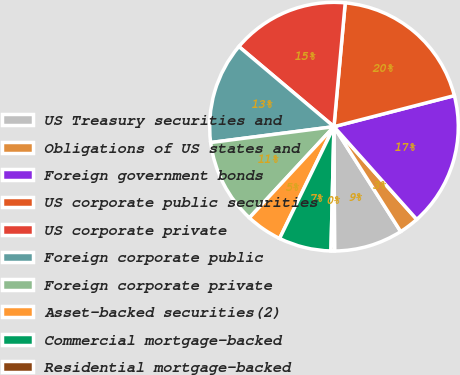Convert chart. <chart><loc_0><loc_0><loc_500><loc_500><pie_chart><fcel>US Treasury securities and<fcel>Obligations of US states and<fcel>Foreign government bonds<fcel>US corporate public securities<fcel>US corporate private<fcel>Foreign corporate public<fcel>Foreign corporate private<fcel>Asset-backed securities(2)<fcel>Commercial mortgage-backed<fcel>Residential mortgage-backed<nl><fcel>8.94%<fcel>2.58%<fcel>17.42%<fcel>19.54%<fcel>15.3%<fcel>13.18%<fcel>11.06%<fcel>4.7%<fcel>6.82%<fcel>0.46%<nl></chart> 